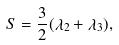Convert formula to latex. <formula><loc_0><loc_0><loc_500><loc_500>S = \frac { 3 } { 2 } ( \lambda _ { 2 } + \lambda _ { 3 } ) ,</formula> 